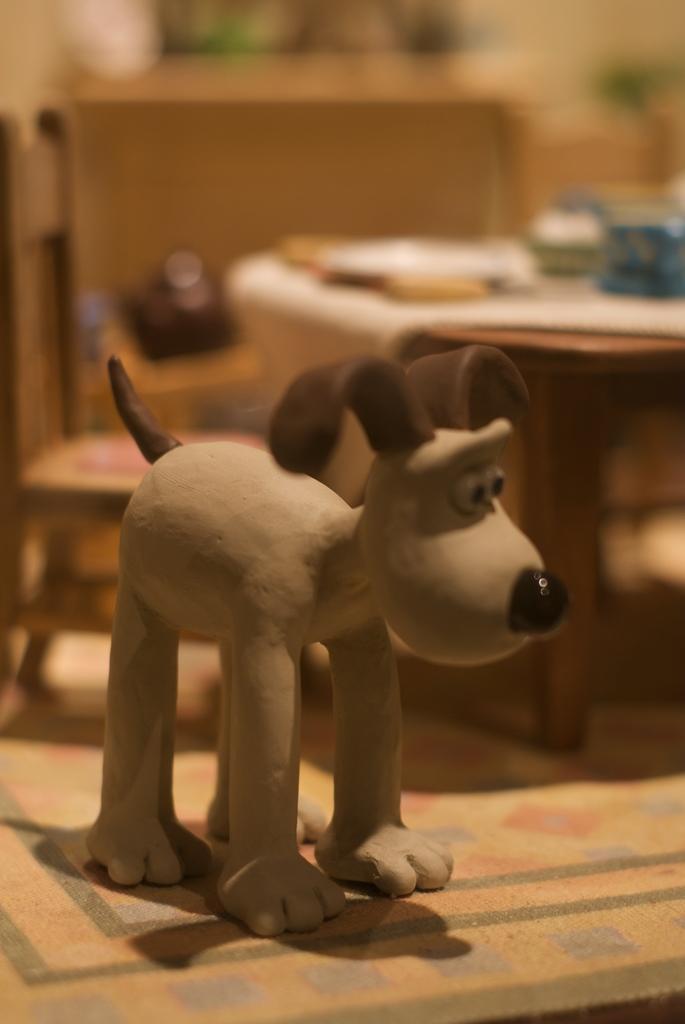Describe this image in one or two sentences. In this image there is a dog made up of clay which is kept on the floor. In the background there is a table and chair. And the background is blurred. 